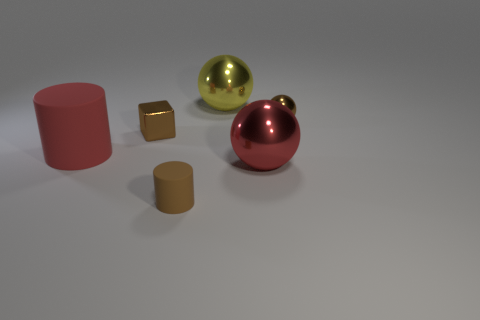Does the cylinder to the left of the brown matte thing have the same color as the shiny thing that is in front of the tiny brown shiny block?
Offer a terse response. Yes. There is a rubber object in front of the large rubber thing; is there a small brown cylinder that is behind it?
Make the answer very short. No. Is the number of large red cylinders that are in front of the small brown cylinder less than the number of rubber cylinders that are to the right of the large matte cylinder?
Provide a short and direct response. Yes. Do the big red object on the left side of the yellow metallic thing and the object that is to the right of the large red metal sphere have the same material?
Provide a succinct answer. No. How many small things are cyan shiny spheres or brown blocks?
Provide a succinct answer. 1. There is a tiny brown object that is made of the same material as the large cylinder; what shape is it?
Your answer should be compact. Cylinder. Is the number of small shiny balls in front of the tiny block less than the number of cubes?
Ensure brevity in your answer.  Yes. Do the yellow metal thing and the large red metallic object have the same shape?
Offer a terse response. Yes. What number of metal objects are either big things or red cylinders?
Your response must be concise. 2. Are there any red rubber objects that have the same size as the brown metal cube?
Your response must be concise. No. 